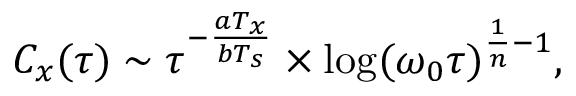Convert formula to latex. <formula><loc_0><loc_0><loc_500><loc_500>\begin{array} { r } { C _ { x } ( \tau ) \sim \tau ^ { - \frac { a T _ { x } } { b T _ { s } } } \times \log ( \omega _ { 0 } \tau ) ^ { \frac { 1 } { n } - 1 } , } \end{array}</formula> 